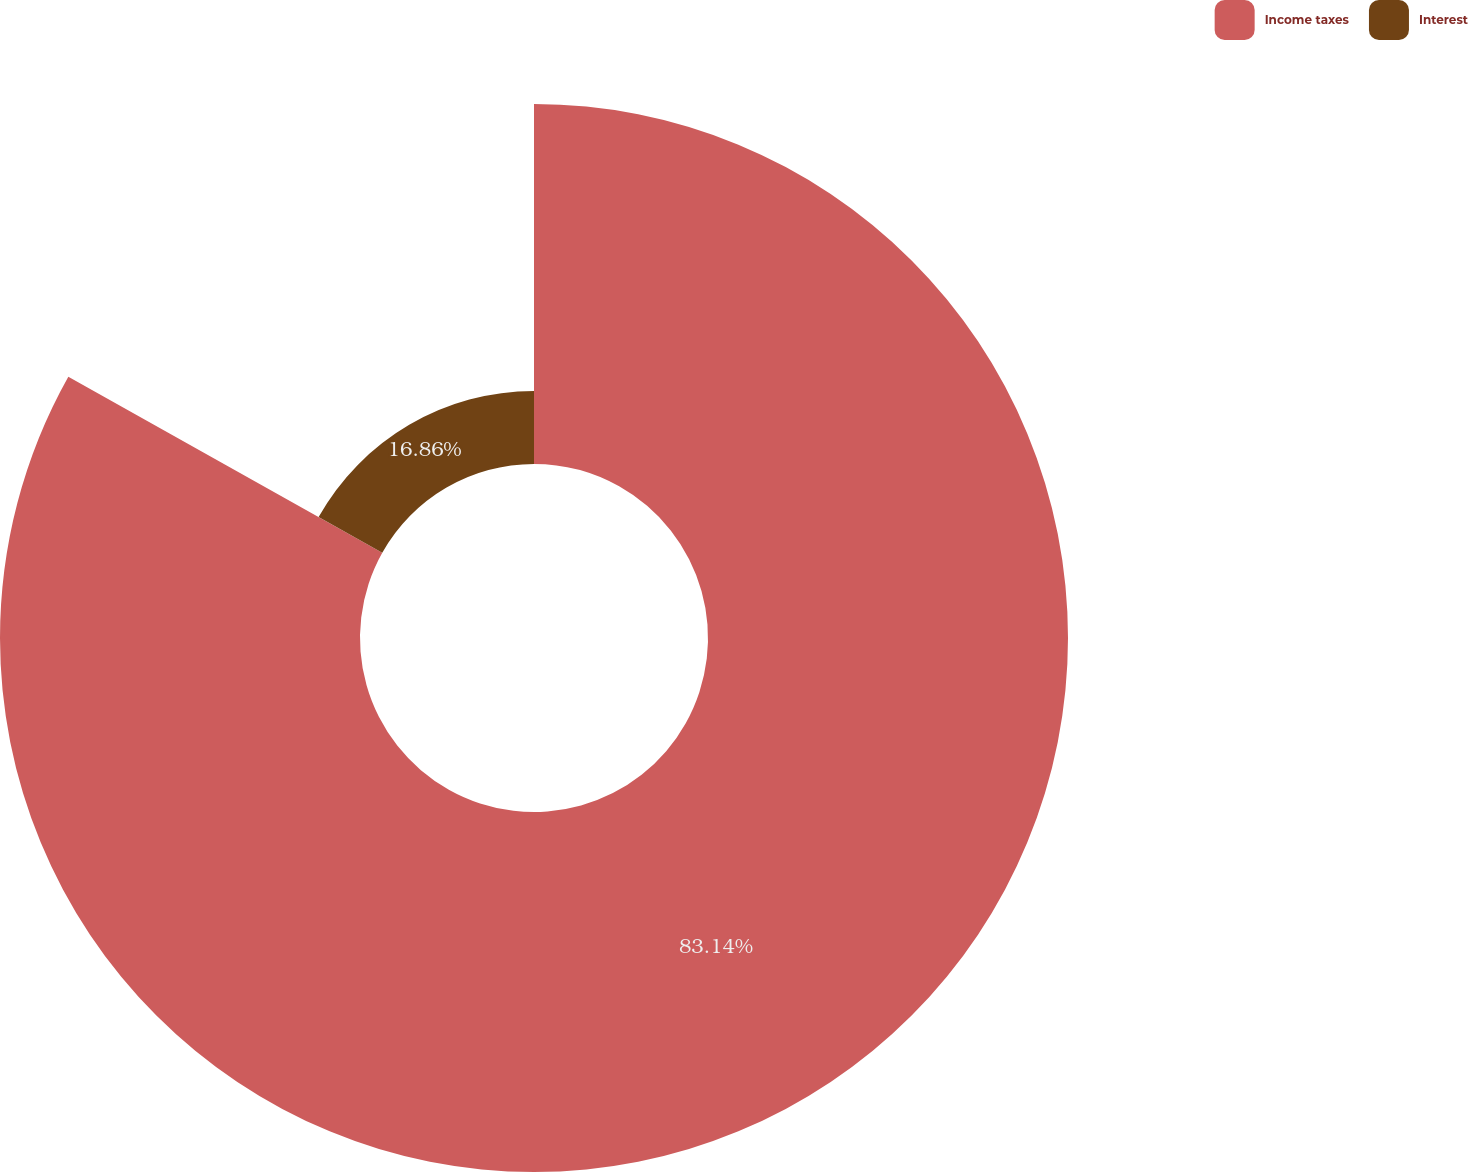Convert chart to OTSL. <chart><loc_0><loc_0><loc_500><loc_500><pie_chart><fcel>Income taxes<fcel>Interest<nl><fcel>83.14%<fcel>16.86%<nl></chart> 